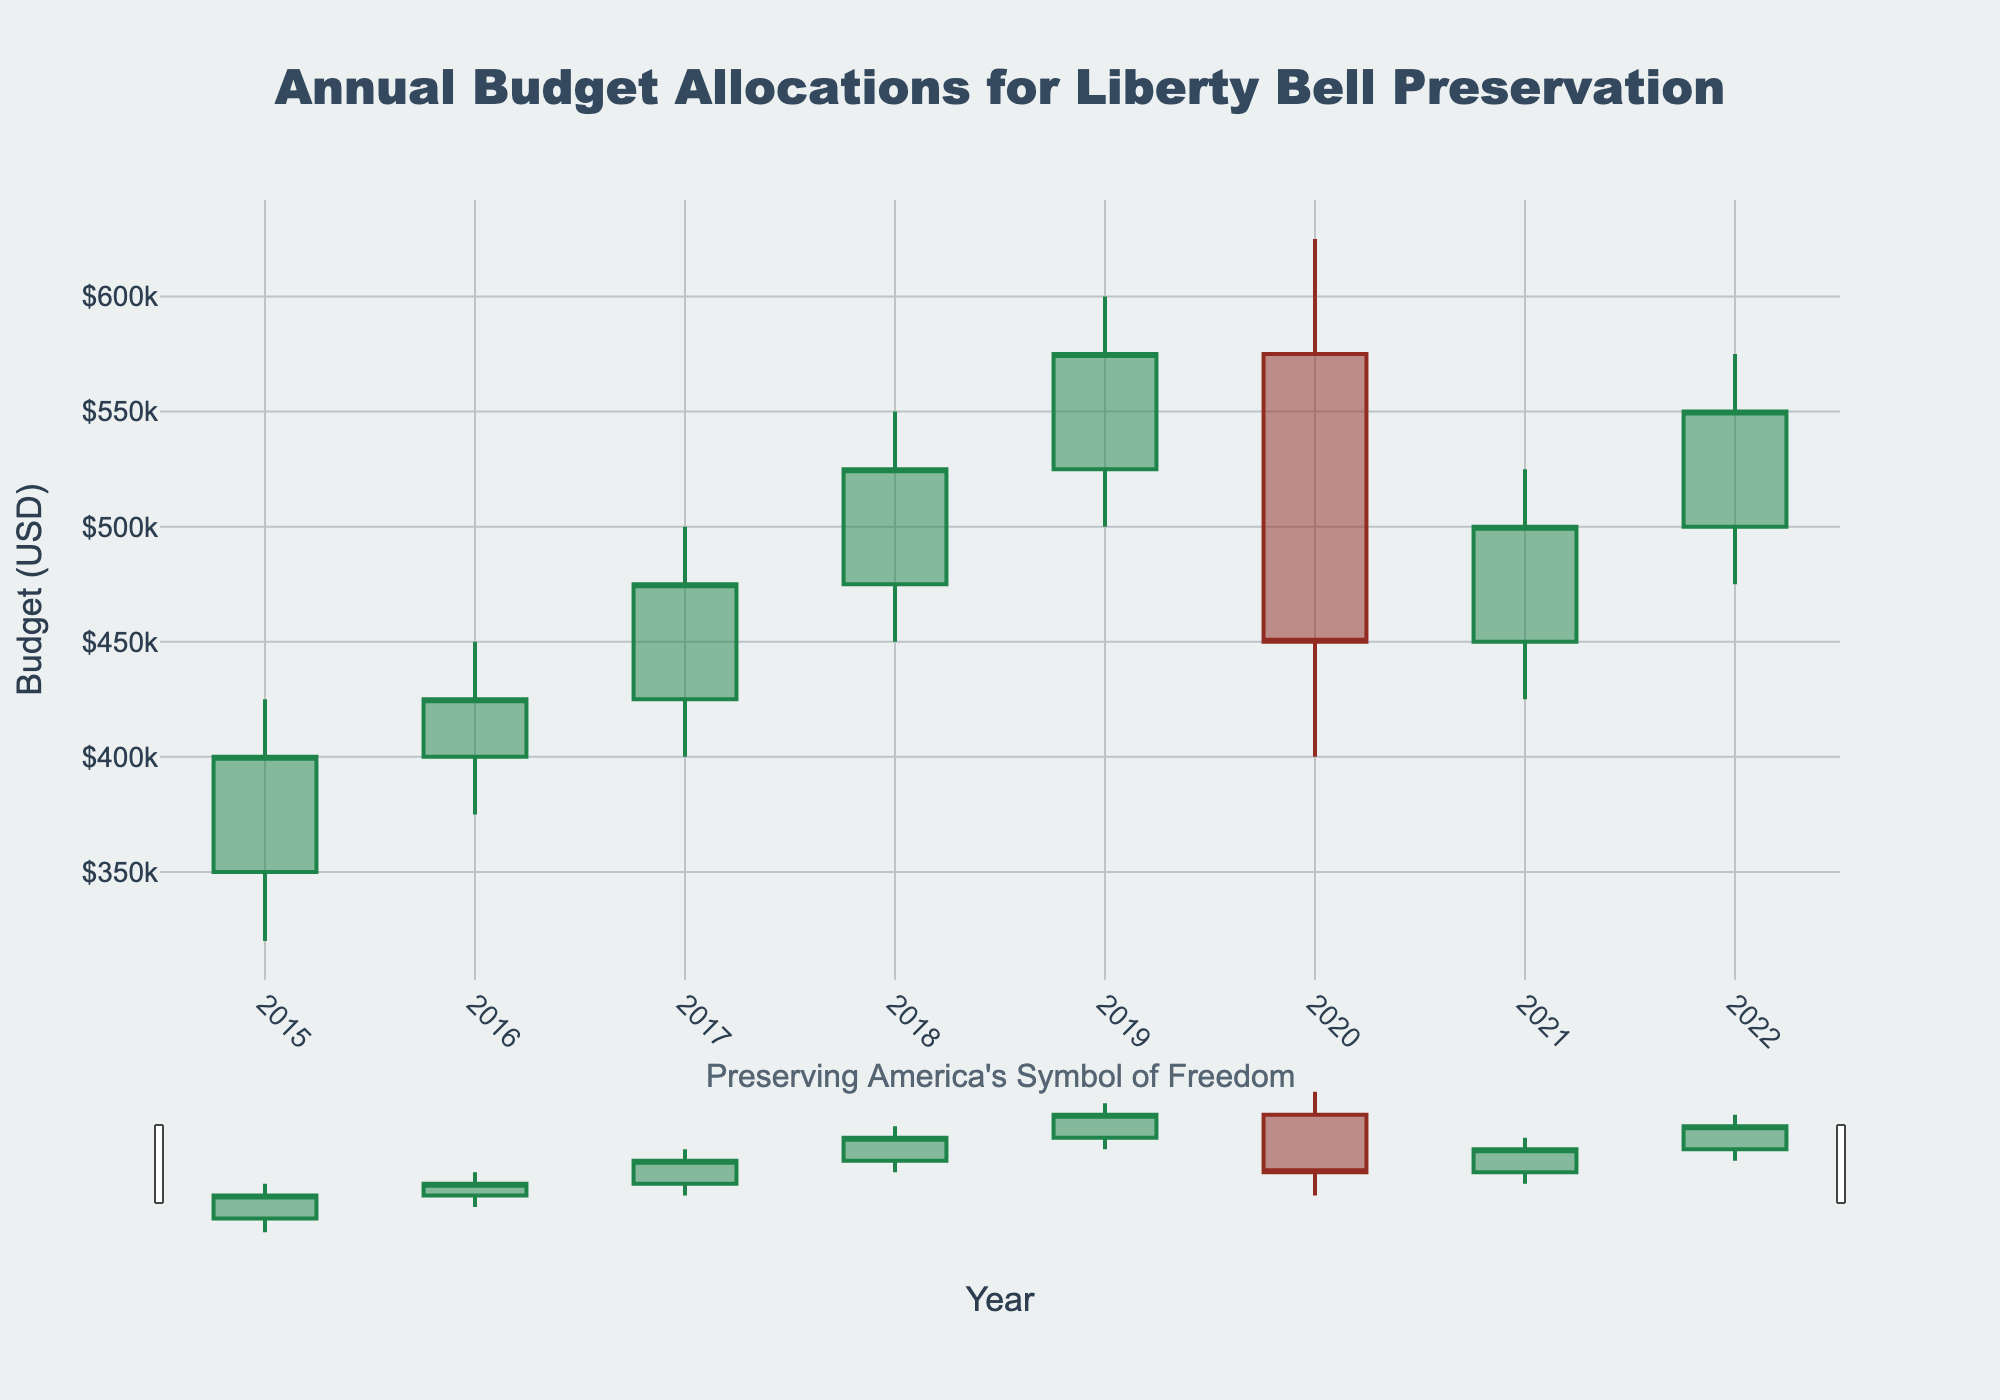what is the title of the chart? The title of the chart is located at the top and is clearly labeled to provide context. The title reads "Annual Budget Allocations for Liberty Bell Preservation."
Answer: Annual Budget Allocations for Liberty Bell Preservation what is the lowest budget allocation in 2020? To find the lowest budget allocation for 2020, locate the year 2020 on the x-axis and identify the lowest point on the corresponding candlestick. The lowest point is labeled as $400,000.
Answer: $400,000 how did the closing budget for Liberty Bell preservation change from 2020 to 2021? Compare the closing budget value at the end of 2020 and 2021. In 2020, the closing value is $450,000, and in 2021, it is $500,000, illustrating an increase of $50,000.
Answer: Increased by $50,000 which year had the highest peak budget for Liberty Bell preservation, and what was that amount? By examining the highest points of the candlesticks across the years, the year with the highest peak budget is 2019 with a peak budget of $600,000.
Answer: 2019, $600,000 what was the trend in the opening budget from 2015 to 2019? Observe the opening (initial) values from 2015 to 2019; starting from $350,000 in 2015, it increases annually, reaching $525,000 in 2019. The trend is consistently upward.
Answer: Upward trend in which year did the closing budget equal the opening budget of the previous year? Observe the closing budget for each year and compare it with the opening budget of the following year. For example, the closing budget in 2015 is $400,000, which equals the opening budget in 2016. A similar comparison shows that the closing budget in 2021 ($500,000) equals the opening budget in 2022.
Answer: 2016 and 2022 what was the average closing budget from 2017 to 2019? Add the closing values for 2017, 2018, and 2019 ($475,000, $525,000, and $575,000) and divide by 3. The sum is $1,575,000, so the average is $1,575,000 / 3 = $525,000.
Answer: $525,000 